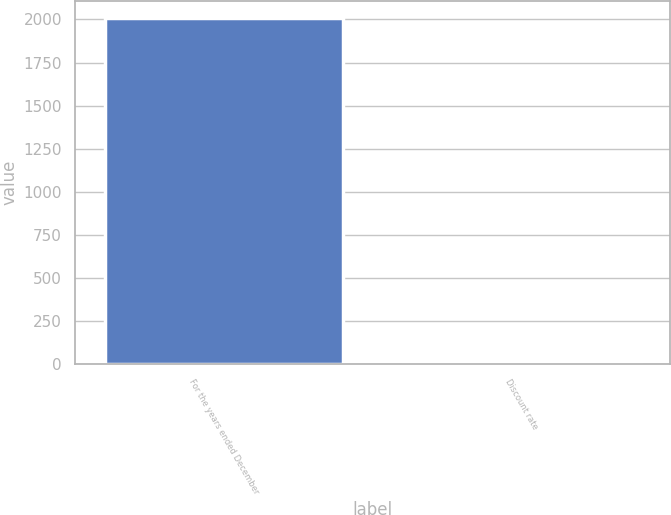Convert chart to OTSL. <chart><loc_0><loc_0><loc_500><loc_500><bar_chart><fcel>For the years ended December<fcel>Discount rate<nl><fcel>2007<fcel>5.8<nl></chart> 